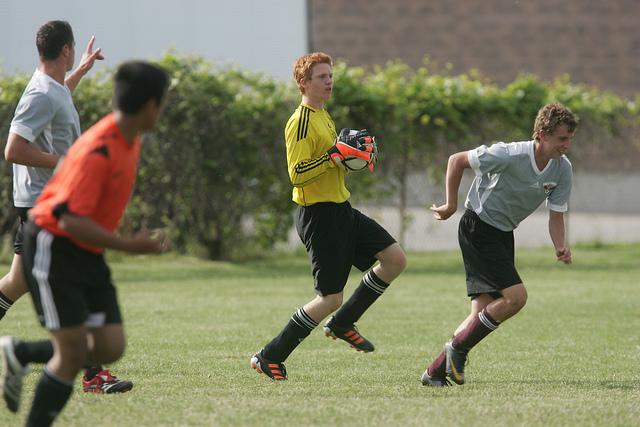What sport is being played?
Concise answer only. Soccer. What are the men jumping to grab?
Short answer required. Ball. Is the boy in yellow touching the ground?
Quick response, please. Yes. What color Jersey is the guy with the fluorescent gloves wearing?
Be succinct. Yellow. 